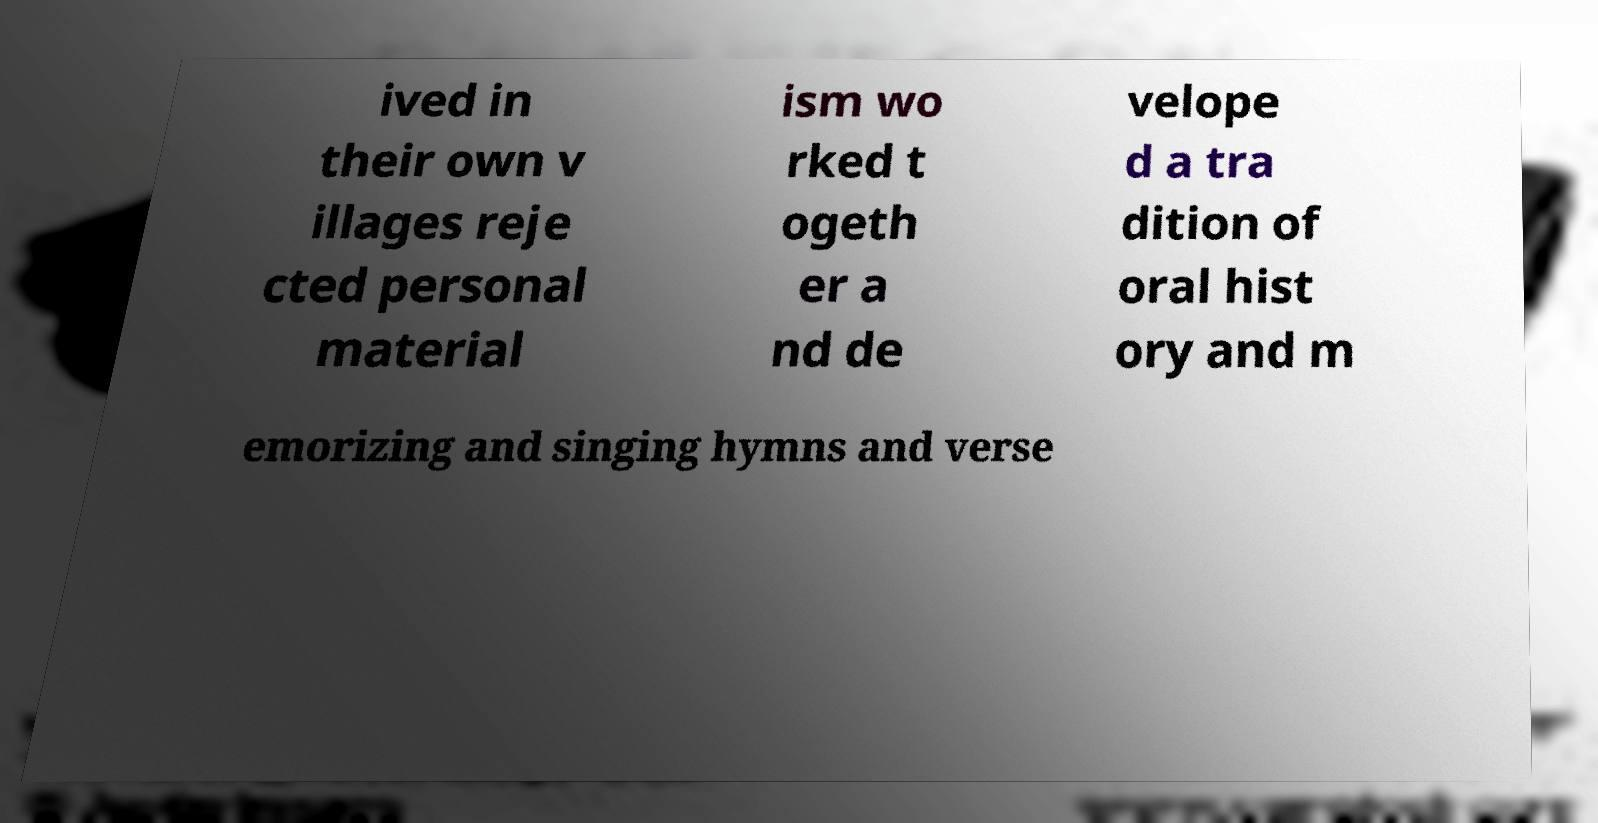Please identify and transcribe the text found in this image. ived in their own v illages reje cted personal material ism wo rked t ogeth er a nd de velope d a tra dition of oral hist ory and m emorizing and singing hymns and verse 